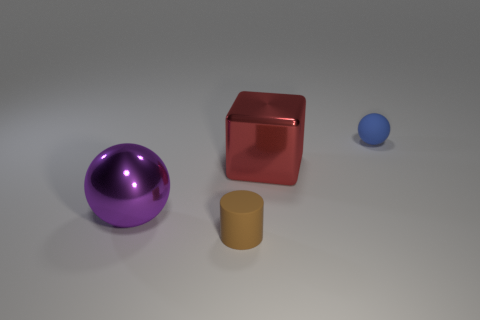There is a tiny object that is right of the brown object; is its color the same as the big thing that is on the left side of the red object?
Offer a terse response. No. Are there any other things that have the same material as the blue thing?
Your answer should be compact. Yes. What size is the blue thing that is the same shape as the big purple thing?
Your response must be concise. Small. Is the number of blue rubber balls to the right of the large block greater than the number of big red metallic blocks?
Provide a short and direct response. No. Does the tiny thing that is to the right of the tiny cylinder have the same material as the purple thing?
Your response must be concise. No. There is a purple thing on the left side of the tiny matte object behind the small brown cylinder on the right side of the big purple ball; what is its size?
Offer a terse response. Large. There is a object that is the same material as the cube; what is its size?
Your answer should be compact. Large. The thing that is both to the left of the blue ball and to the right of the brown matte thing is what color?
Your response must be concise. Red. There is a big purple object that is to the left of the cylinder; does it have the same shape as the small thing behind the red block?
Give a very brief answer. Yes. There is a tiny thing that is right of the large shiny block; what is its material?
Provide a succinct answer. Rubber. 